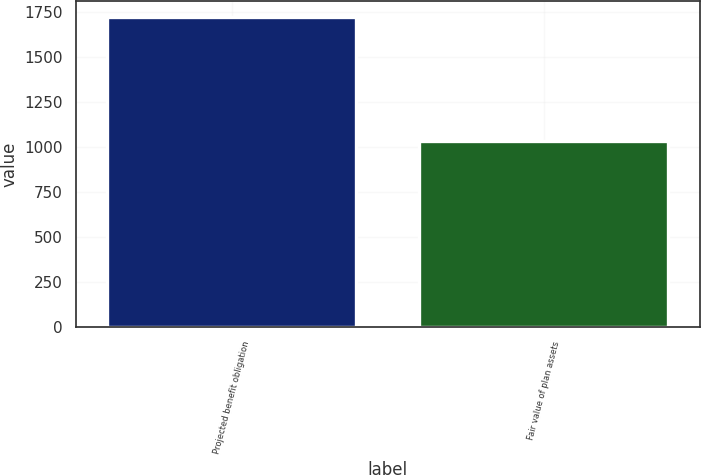Convert chart to OTSL. <chart><loc_0><loc_0><loc_500><loc_500><bar_chart><fcel>Projected benefit obligation<fcel>Fair value of plan assets<nl><fcel>1726<fcel>1032<nl></chart> 